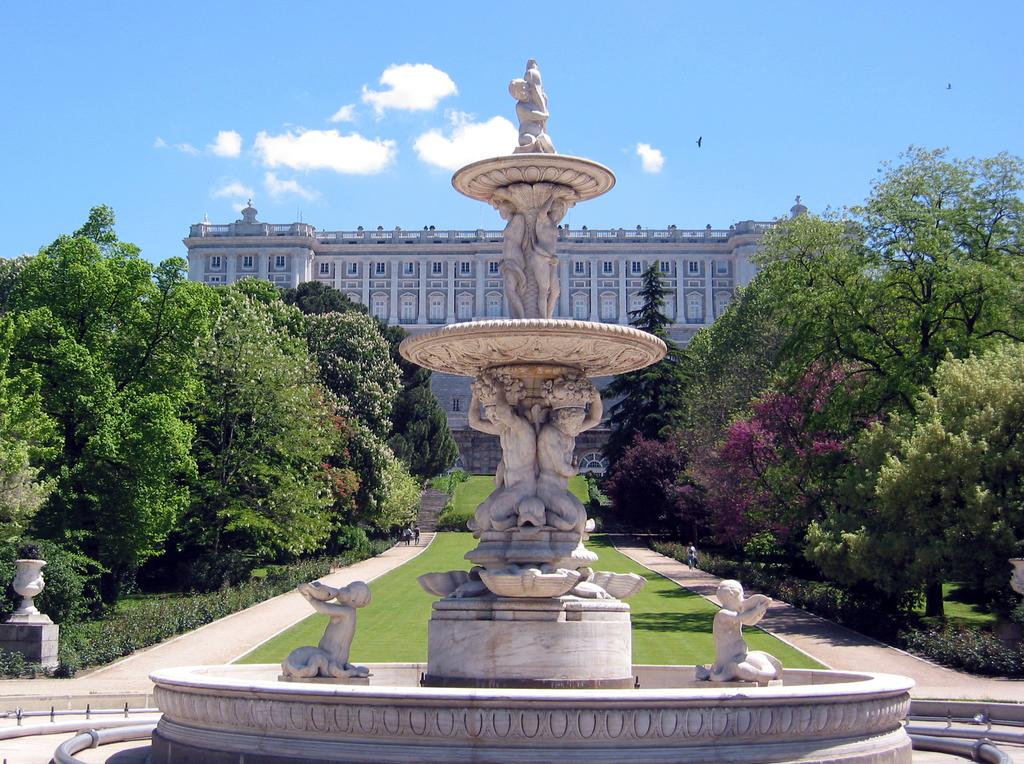What is the main subject in the image? There is a statue in the image. What can be seen on the left side of the image? There are trees on the left side of the image. What can be seen on the right side of the image? There are trees on the right side of the image. What is visible in the background of the image? There is a building and clouds in the sky in the background of the image. What type of pest can be seen crawling on the statue in the image? There are no pests visible on the statue in the image. What material is the feather made of that is attached to the statue? There is no feather attached to the statue in the image. 